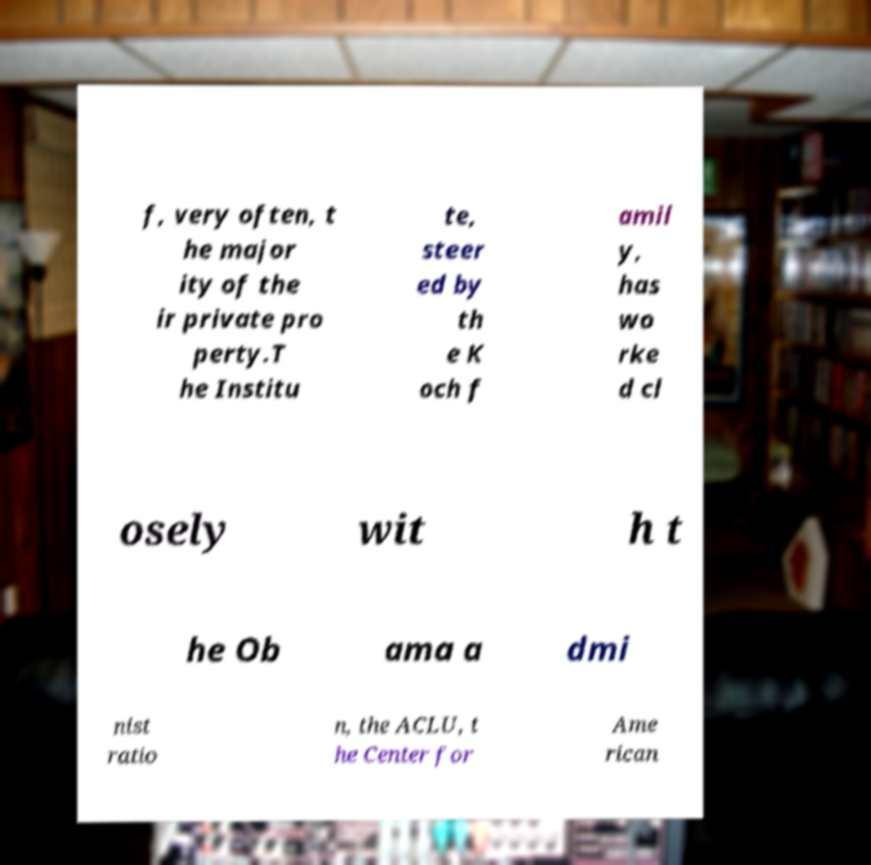Could you assist in decoding the text presented in this image and type it out clearly? f, very often, t he major ity of the ir private pro perty.T he Institu te, steer ed by th e K och f amil y, has wo rke d cl osely wit h t he Ob ama a dmi nist ratio n, the ACLU, t he Center for Ame rican 